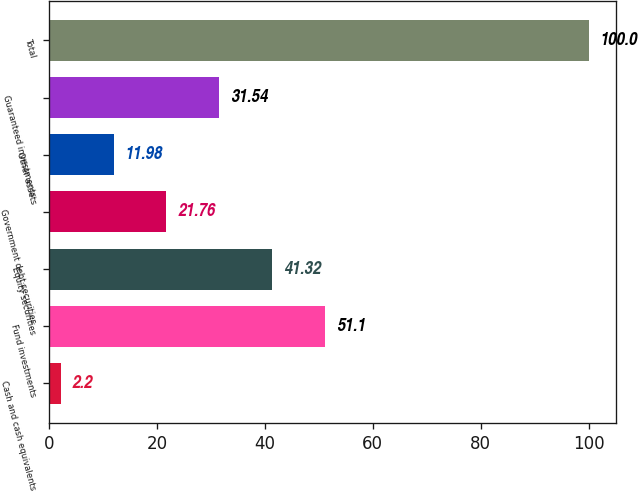Convert chart. <chart><loc_0><loc_0><loc_500><loc_500><bar_chart><fcel>Cash and cash equivalents<fcel>Fund investments<fcel>Equity securities<fcel>Government debt securities<fcel>Other assets<fcel>Guaranteed investments<fcel>Total<nl><fcel>2.2<fcel>51.1<fcel>41.32<fcel>21.76<fcel>11.98<fcel>31.54<fcel>100<nl></chart> 